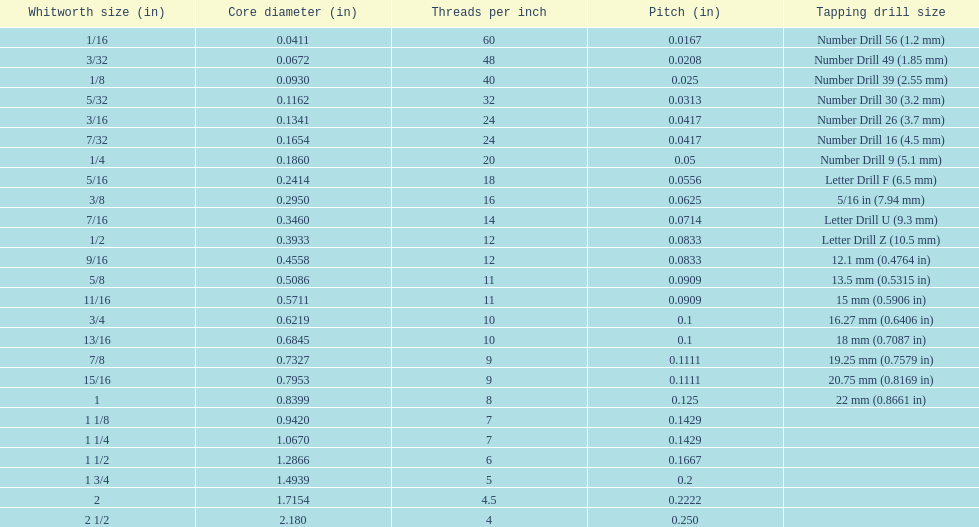Which single whitworth size features 5 threads per inch? 1 3/4. 